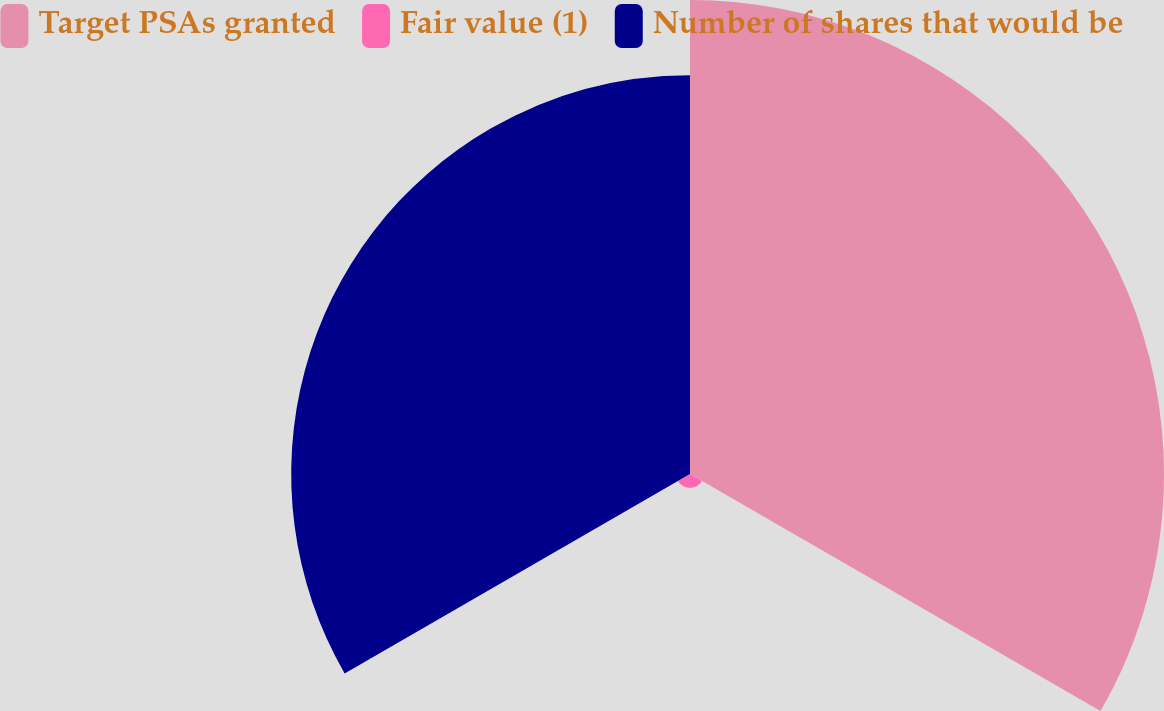Convert chart. <chart><loc_0><loc_0><loc_500><loc_500><pie_chart><fcel>Target PSAs granted<fcel>Fair value (1)<fcel>Number of shares that would be<nl><fcel>53.46%<fcel>1.56%<fcel>44.98%<nl></chart> 